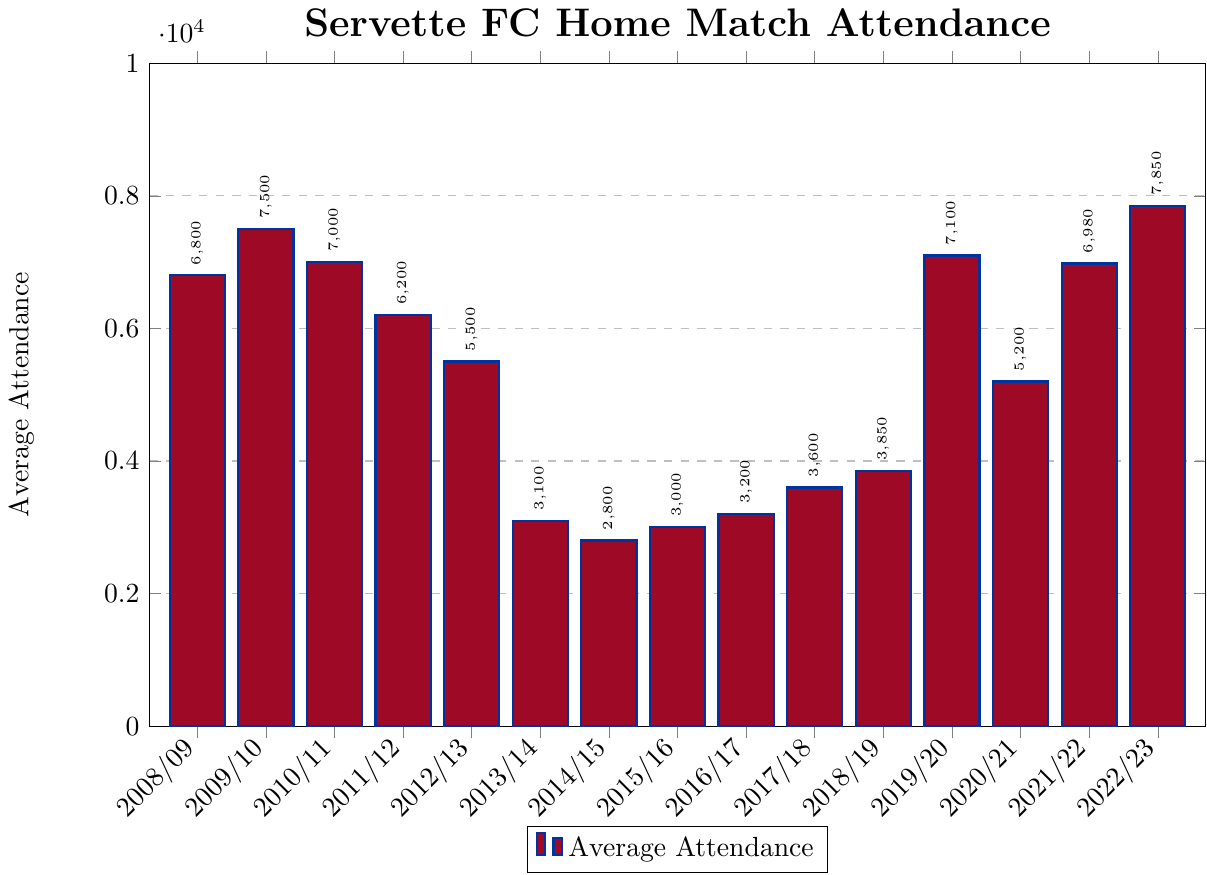what season had the lowest average attendance? Scan the chart for the shortest bar because the bar height represents attendance figures. The shortest bar corresponds to the 2014/2015 season.
Answer: 2014/2015 how much higher was the attendance in 2022/2023 compared to 2020/2021? Find and subtract the attendance in 2020/2021 (5200) from the attendance in 2022/2023 (7850). So, 7850 - 5200 = 2650
Answer: 2650 which seasons had an average attendance greater than 7000? Scan the chart for bars higher than 7000. The seasons above 7000 are 2009/2010, 2010/2011, 2019/2020, and 2022/2023.
Answer: 2009/2010, 2010/2011, 2019/2020, 2022/2023 was the average attendance ever equal to 3000? Inspect each bar for a height matching 3000. The bar for the 2015/2016 season has an average attendance of 3000.
Answer: Yes what was the average attendance for 2018/2019 and 2019/2020 combined? Sum the average attendances of 2018/2019 (3850) and 2019/2020 (7100). So, 3850 + 7100 = 10950
Answer: 10950 which season saw the highest increase in attendance compared to the previous season? Calculate the difference between attendance figures of consecutive seasons and identify the largest increase. The largest increase is from 2021/2022 (6980) to 2022/2023 (7850): 7850 - 6980 = 870
Answer: 2022/2023 how did the average attendance in 2011/2012 compare to that in 2012/2013? Subtract the average attendance of 2012/2013 (5500) from 2011/2012 (6200). The difference is 6200 - 5500 = 700
Answer: 700 higher what is the range of average attendance figures across all seasons? Subtract the minimum average attendance (2014/2015: 2800) from the maximum average attendance (2022/2023: 7850). So, 7850 - 2800 = 5050
Answer: 5050 were there more than 5 seasons with an average attendance below 4000? Count the number of bars with a height below 4000. These seasons are 2013/2014, 2014/2015, 2015/2016, 2016/2017, 2017/2018 and 2018/2019, making it 6 seasons in total.
Answer: Yes how many seasons had an average attendance between 5000 and 7000? Count the bars that fall between the heights of 5000 and 7000. The seasons are 2008/2009, 2011/2012, 2012/2013, and 2020/2021, making it 4 seasons in total.
Answer: 4 